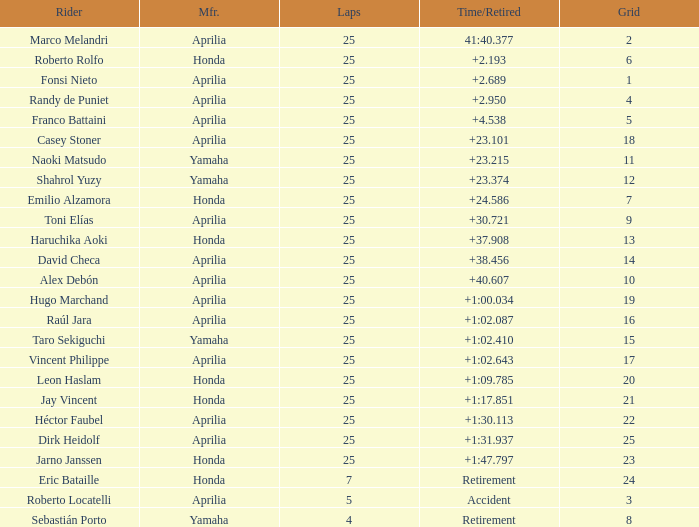Which Laps have a Time/Retired of +23.215, and a Grid larger than 11? None. Could you parse the entire table as a dict? {'header': ['Rider', 'Mfr.', 'Laps', 'Time/Retired', 'Grid'], 'rows': [['Marco Melandri', 'Aprilia', '25', '41:40.377', '2'], ['Roberto Rolfo', 'Honda', '25', '+2.193', '6'], ['Fonsi Nieto', 'Aprilia', '25', '+2.689', '1'], ['Randy de Puniet', 'Aprilia', '25', '+2.950', '4'], ['Franco Battaini', 'Aprilia', '25', '+4.538', '5'], ['Casey Stoner', 'Aprilia', '25', '+23.101', '18'], ['Naoki Matsudo', 'Yamaha', '25', '+23.215', '11'], ['Shahrol Yuzy', 'Yamaha', '25', '+23.374', '12'], ['Emilio Alzamora', 'Honda', '25', '+24.586', '7'], ['Toni Elías', 'Aprilia', '25', '+30.721', '9'], ['Haruchika Aoki', 'Honda', '25', '+37.908', '13'], ['David Checa', 'Aprilia', '25', '+38.456', '14'], ['Alex Debón', 'Aprilia', '25', '+40.607', '10'], ['Hugo Marchand', 'Aprilia', '25', '+1:00.034', '19'], ['Raúl Jara', 'Aprilia', '25', '+1:02.087', '16'], ['Taro Sekiguchi', 'Yamaha', '25', '+1:02.410', '15'], ['Vincent Philippe', 'Aprilia', '25', '+1:02.643', '17'], ['Leon Haslam', 'Honda', '25', '+1:09.785', '20'], ['Jay Vincent', 'Honda', '25', '+1:17.851', '21'], ['Héctor Faubel', 'Aprilia', '25', '+1:30.113', '22'], ['Dirk Heidolf', 'Aprilia', '25', '+1:31.937', '25'], ['Jarno Janssen', 'Honda', '25', '+1:47.797', '23'], ['Eric Bataille', 'Honda', '7', 'Retirement', '24'], ['Roberto Locatelli', 'Aprilia', '5', 'Accident', '3'], ['Sebastián Porto', 'Yamaha', '4', 'Retirement', '8']]} 